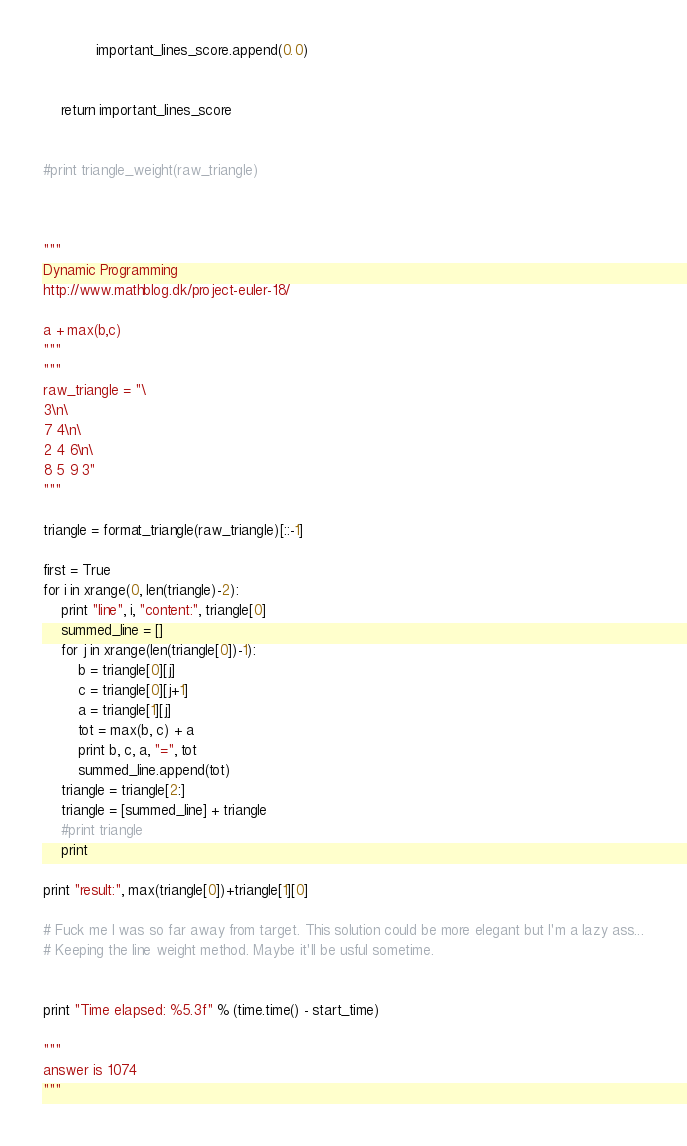Convert code to text. <code><loc_0><loc_0><loc_500><loc_500><_Python_>			important_lines_score.append(0.0)
	

	return important_lines_score


#print triangle_weight(raw_triangle)



"""
Dynamic Programming
http://www.mathblog.dk/project-euler-18/

a + max(b,c)
"""
"""
raw_triangle = "\
3\n\
7 4\n\
2 4 6\n\
8 5 9 3"
"""

triangle = format_triangle(raw_triangle)[::-1]

first = True
for i in xrange(0, len(triangle)-2):
	print "line", i, "content:", triangle[0]
	summed_line = []
	for j in xrange(len(triangle[0])-1):
		b = triangle[0][j]
		c = triangle[0][j+1]
		a = triangle[1][j]
		tot = max(b, c) + a
		print b, c, a, "=", tot
		summed_line.append(tot)
	triangle = triangle[2:]
	triangle = [summed_line] + triangle
	#print triangle
	print

print "result:", max(triangle[0])+triangle[1][0]

# Fuck me I was so far away from target. This solution could be more elegant but I'm a lazy ass...
# Keeping the line weight method. Maybe it'll be usful sometime.


print "Time elapsed: %5.3f" % (time.time() - start_time)

"""
answer is 1074
"""



</code> 